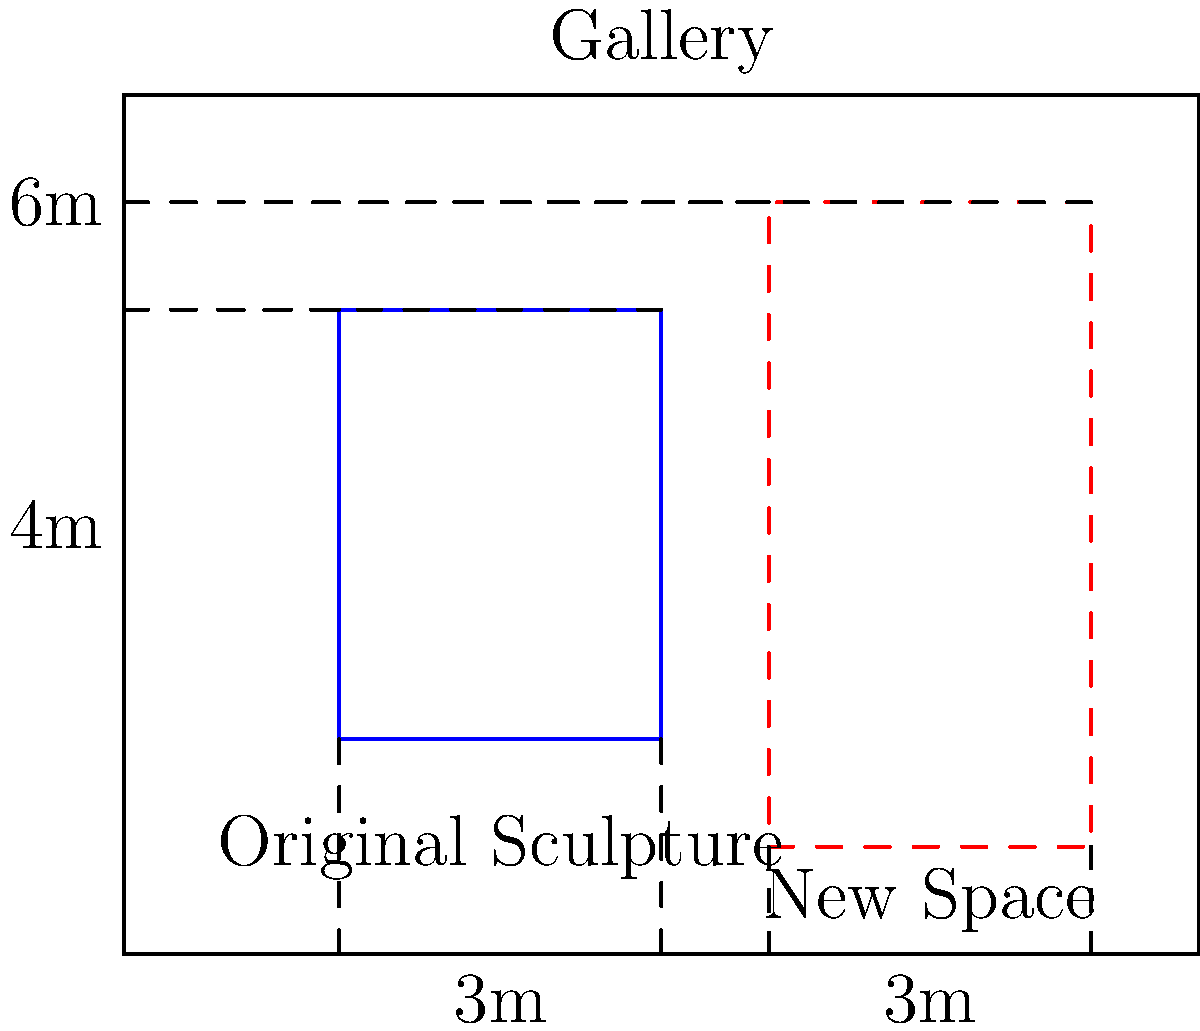As a cultural enthusiast attending an art exhibit, you notice a sculpture needs to be resized for a new gallery space. The original sculpture measures 3m wide and 4m tall. The new space is 3m wide and 6m tall. To maintain the sculpture's proportions, what should be its new height? Let's approach this step-by-step:

1) First, we need to understand what it means to maintain proportions. It means the ratio of width to height should remain the same.

2) Let's calculate the original ratio:
   Original ratio = width : height = 3 : 4

3) Now, we know the new width is 3m (same as original). Let's call the new height $x$.

4) To maintain proportions, we need:
   3 : 4 = 3 : $x$

5) This can be written as an equation:
   $\frac{3}{4} = \frac{3}{x}$

6) Cross multiply:
   $3x = 4 \cdot 3 = 12$

7) Solve for $x$:
   $x = \frac{12}{3} = 4$

Therefore, to maintain the same proportions, the new height should be 4m.

8) Let's verify if this fits in the new space:
   The new space is 6m tall, and our calculated height is 4m, so it fits perfectly with room to spare.
Answer: 4m 